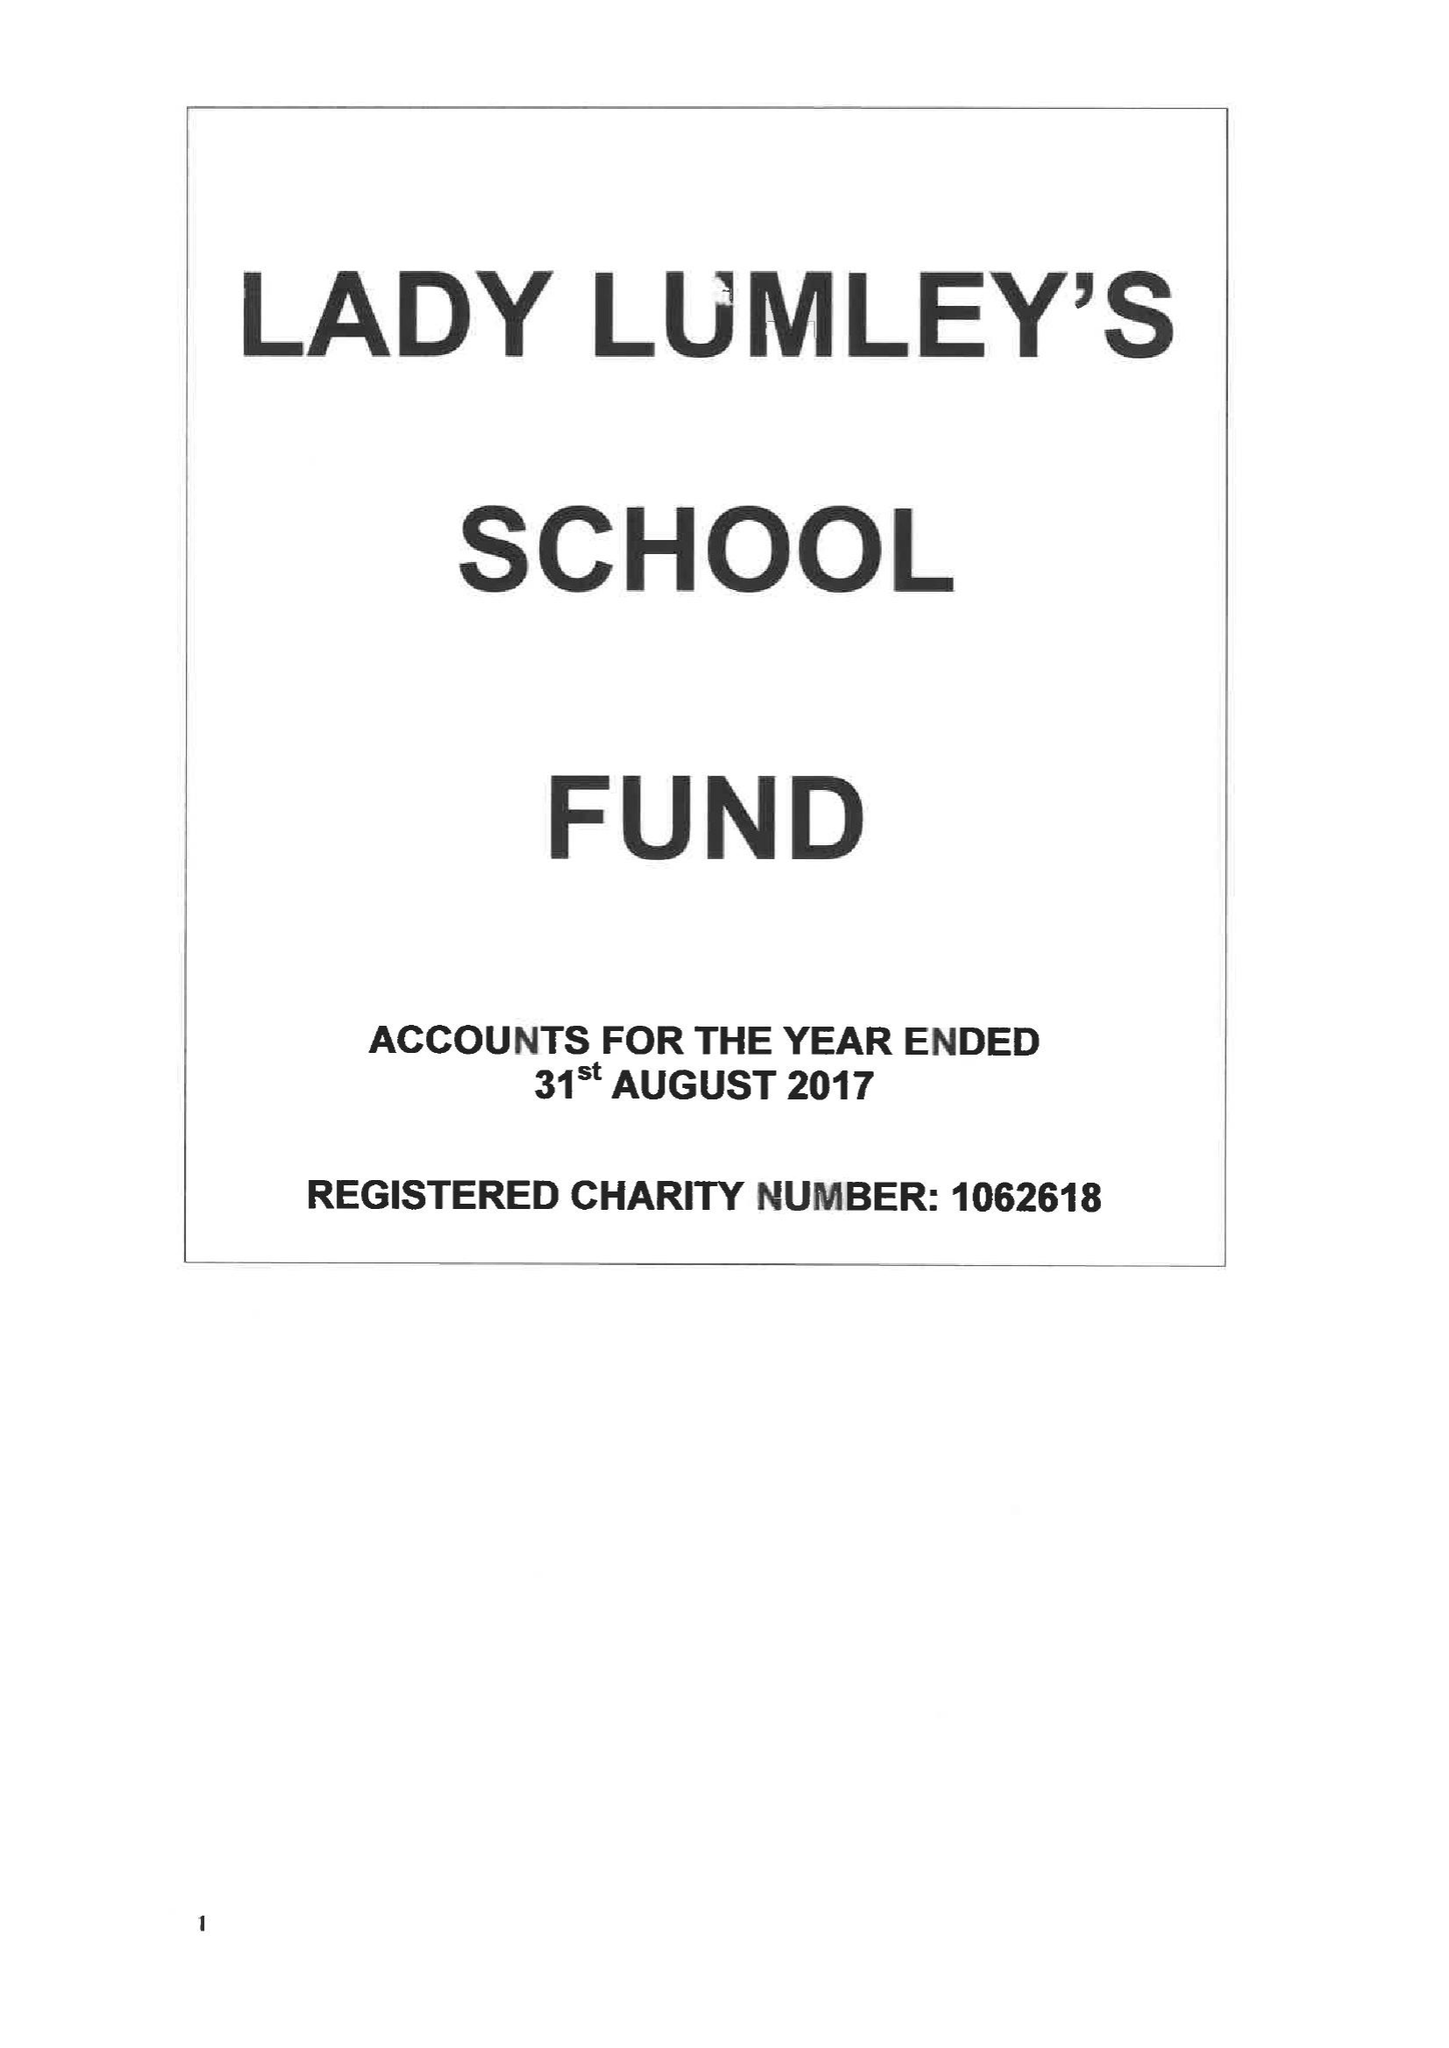What is the value for the address__post_town?
Answer the question using a single word or phrase. PICKERING 